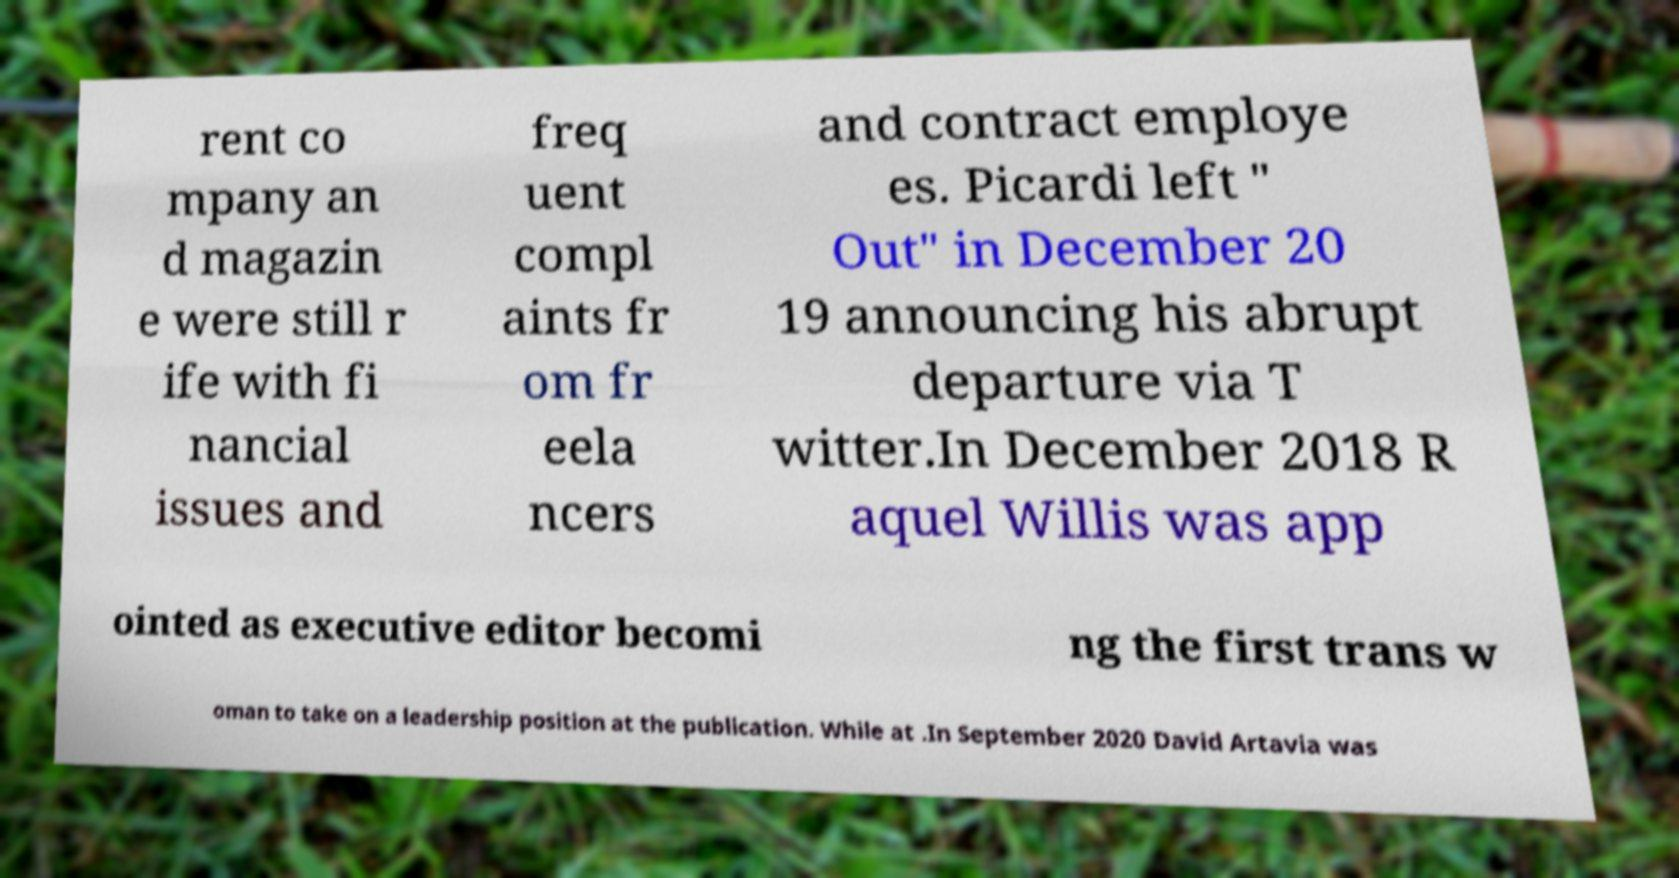Can you read and provide the text displayed in the image?This photo seems to have some interesting text. Can you extract and type it out for me? rent co mpany an d magazin e were still r ife with fi nancial issues and freq uent compl aints fr om fr eela ncers and contract employe es. Picardi left " Out" in December 20 19 announcing his abrupt departure via T witter.In December 2018 R aquel Willis was app ointed as executive editor becomi ng the first trans w oman to take on a leadership position at the publication. While at .In September 2020 David Artavia was 